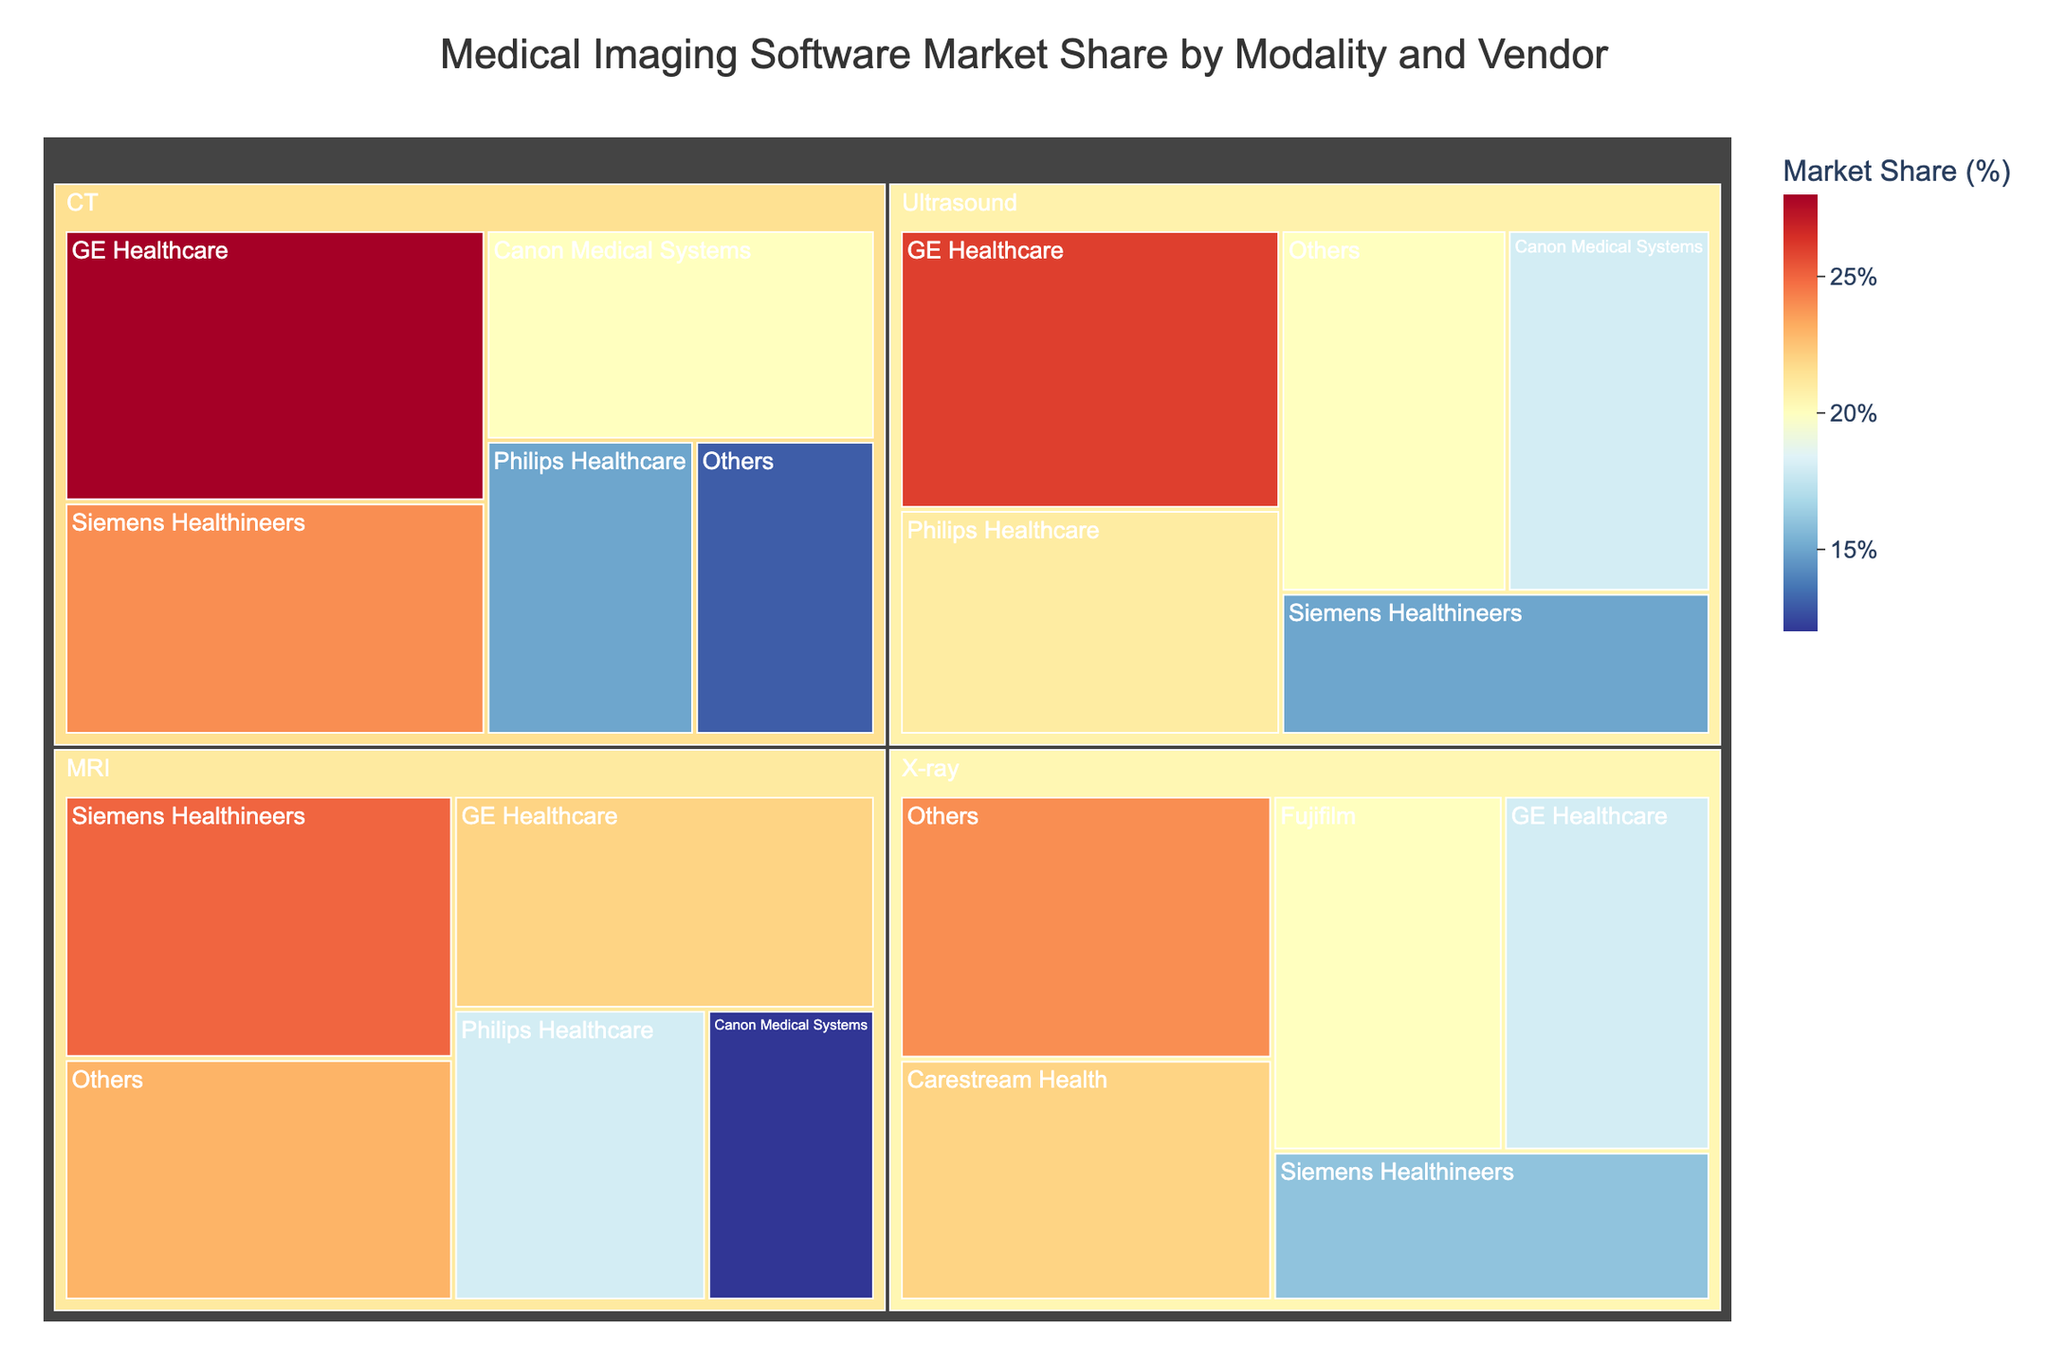What's the title of the Treemap? The Treemap's title is positioned at the top center of the figure, written in a larger, bolded font for prominence.
Answer: Medical Imaging Software Market Share by Modality and Vendor Which vendor has the largest market share in the MRI modality? The MRI section in the Treemap can be examined, where the relative size of each vendor's segment indicates their market share. The largest segment in MRI is Siemens Healthineers.
Answer: Siemens Healthineers What is the combined market share of Siemens Healthineers across all modalities? By summing up the market shares from Siemens Healthineers in MRI (25%), CT (24%), X-ray (16%), and Ultrasound (15%), you get the total market share.
Answer: 80% Which modality has the largest share for GE Healthcare? GE Healthcare's segments in each modality section of the Treemap can be compared visually. The largest segment for GE Healthcare is in the CT modality at 28%.
Answer: CT What is the total market share of all 'Others' categories combined across all modalities? Summing up the market shares from 'Others' in MRI (23%), CT (13%), X-ray (24%), and Ultrasound (20%) gives the total market share.
Answer: 80% What's the smallest market share value present in the Treemap, and which vendor and modality does it correspond to? By examining all segments, the smallest market share value is 12% for Canon Medical Systems in the MRI modality.
Answer: 12%, Canon Medical Systems in MRI How does the market share of Philips Healthcare in MRI compare to its share in Ultrasound? By comparing the segment sizes, Philips Healthcare has an 18% share in MRI and a 21% share in Ultrasound. The market share in Ultrasound is larger than in MRI.
Answer: Ultrasound (21%) > MRI (18%) Which modality has the most evenly distributed market shares among all vendors? By visually inspecting the sections for each modality, the X-ray modality appears to have segments closest in size, indicating more evenly distributed shares among all vendors.
Answer: X-ray What is the average market share of vendors in the CT modality? Adding the market shares in CT (GE Healthcare: 28%, Siemens Healthineers: 24%, Canon Medical Systems: 20%, Philips Healthcare: 15%, Others: 13%) and dividing by the number of vendors (5) gives the average market share.
Answer: 20% Which vendor and modality combination represents the largest overall market share? The segments in each modality can be compared, and the largest segment overall belongs to GE Healthcare in the CT modality with a 28% share.
Answer: GE Healthcare in CT 